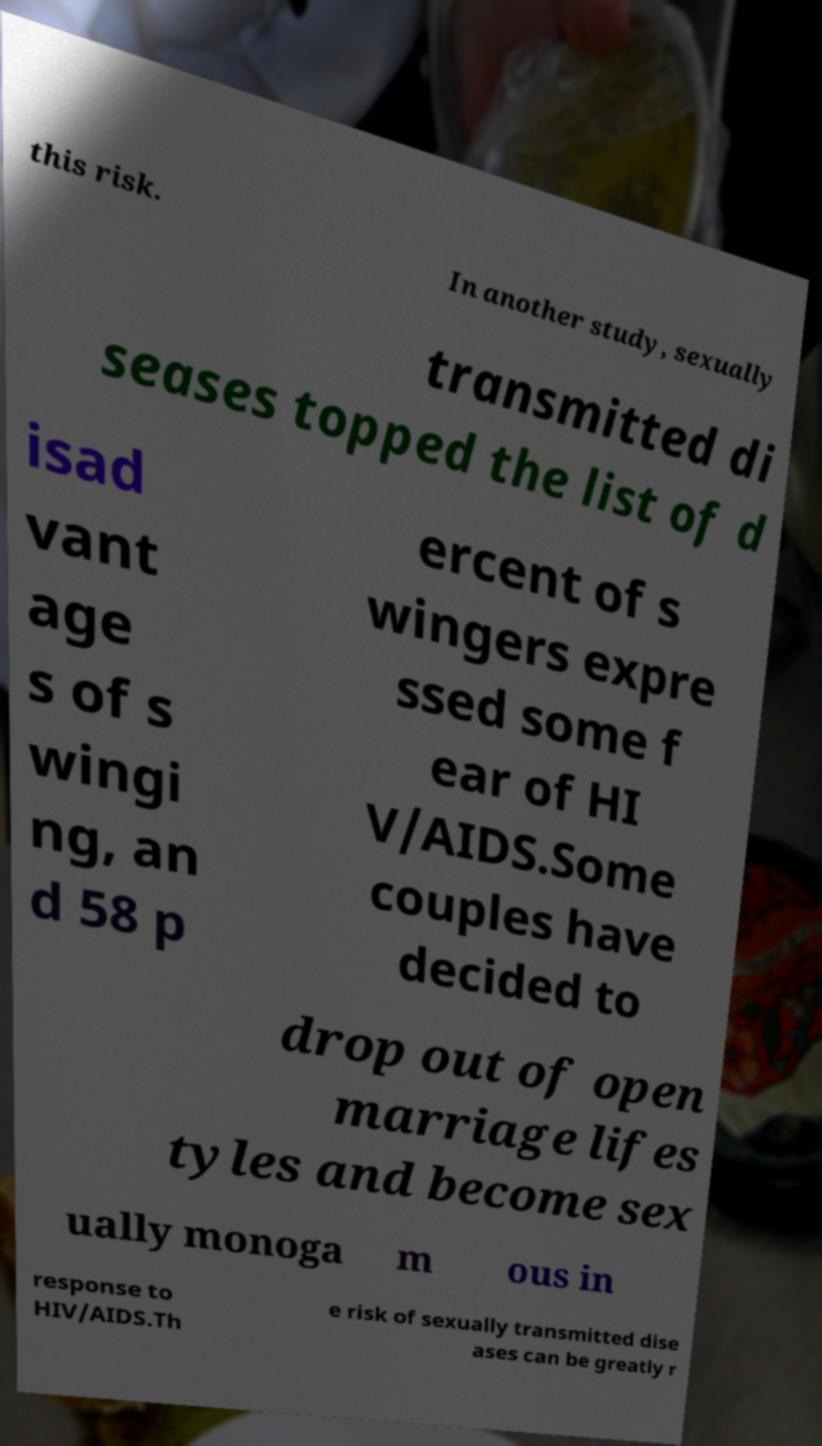Please identify and transcribe the text found in this image. this risk. In another study, sexually transmitted di seases topped the list of d isad vant age s of s wingi ng, an d 58 p ercent of s wingers expre ssed some f ear of HI V/AIDS.Some couples have decided to drop out of open marriage lifes tyles and become sex ually monoga m ous in response to HIV/AIDS.Th e risk of sexually transmitted dise ases can be greatly r 